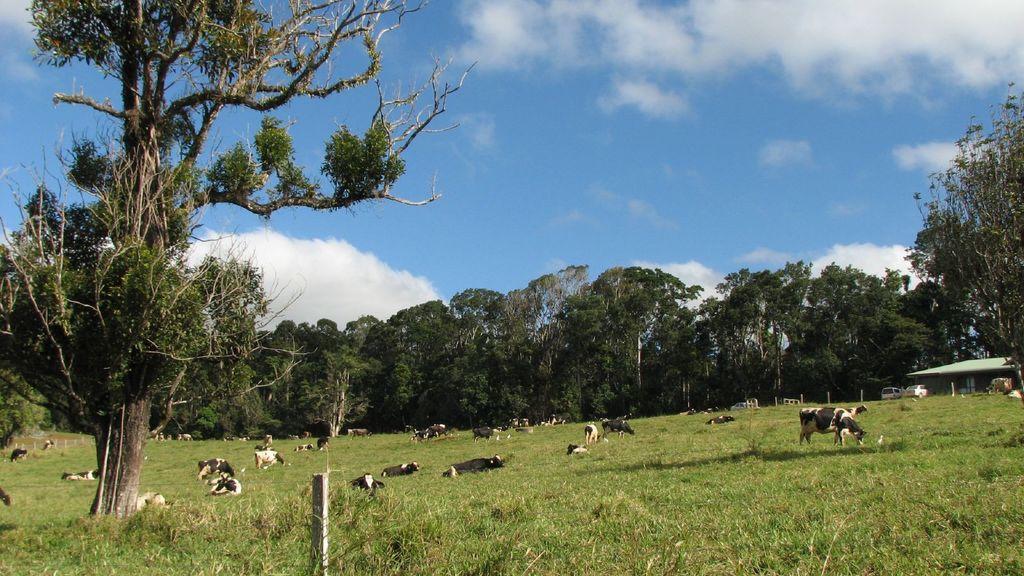Could you give a brief overview of what you see in this image? In this image we can see some animals on the ground and there are some trees and grass on the ground. We can see some vehicles and there is a house on the right side of the image and at the top we can see the sky with clouds. 